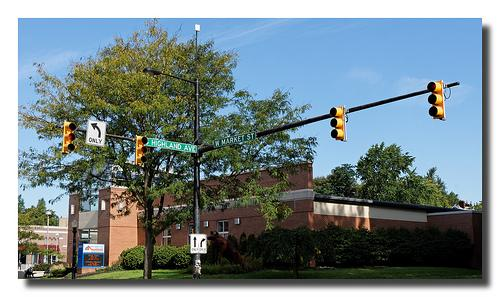Describe the appearance of the school building in the image. The school building is made of brick, light brown in color, and has trees and shrubs in front of it. Describe any distinct elements visible on the turn left only sign. The turn left only sign is white and black with two arrows on it. What type of sign is visible next to the traffic light? There is a turn left only sign next to the traffic light. Identify the colors of the traffic light in the image. The traffic light has three colors: yellow, green, and red. What kind of sign can be seen outside the school building? There is a digital school sign outside the building with electronic text. Describe any unusual features of the street lights in the image. There are two traffic lights on a metal pole and one of them shows a yellow signal. What specific road names are displayed on the green street sign? The road names displayed on the green street sign are "Highland Ave" and "W Market St." What is the color of the pole that holds the traffic lights? The pole holding the traffic lights is black in color. Mention the type and colors of the street sign in the picture. The street sign is green and white with the words "Highland Ave" and "W Market St" written on it. What type of trees can be seen in front of the school building? There is a green tree on the sidewalk and a row of green shrubs in front of the school building. 